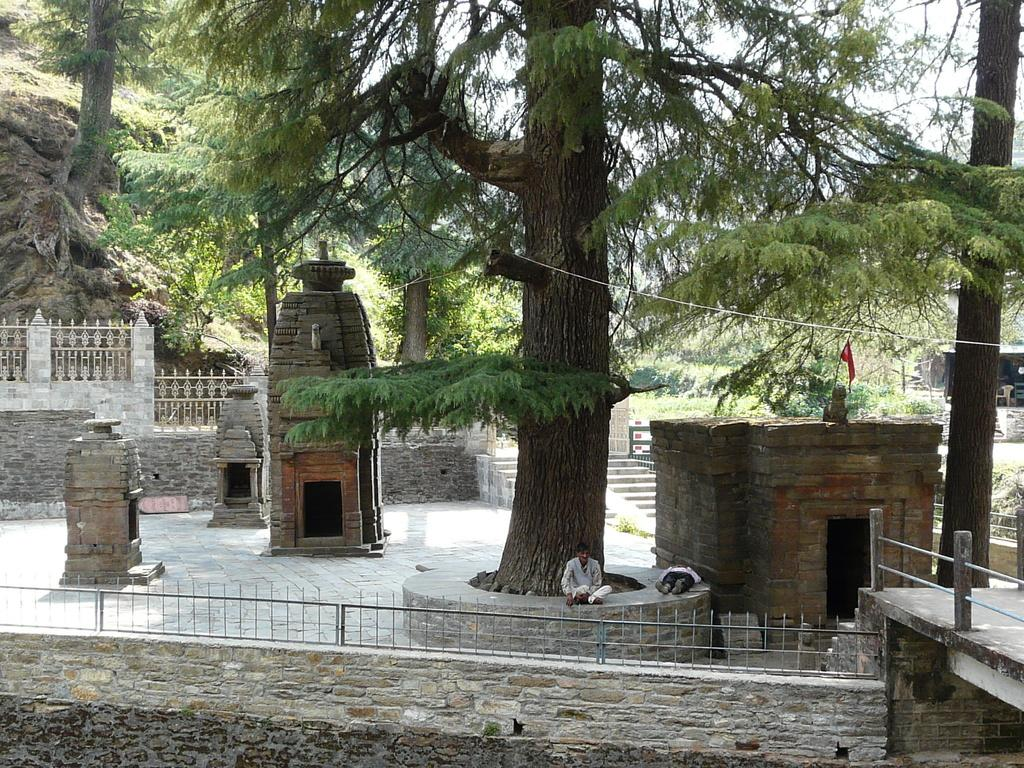What type of structures are visible in the image? There are temples made with bricks in the image. How many people are present in the image? There are two persons in the image. What can be seen in the background of the image? There are trees in the background of the image. What is the color of the trees? The trees are green in color. What is visible above the trees in the image? The sky is visible in the image. What is the color of the sky? The sky is white in color. What type of engine can be seen powering the temples in the image? There is no engine present in the image, and the temples are not powered by any machinery. 